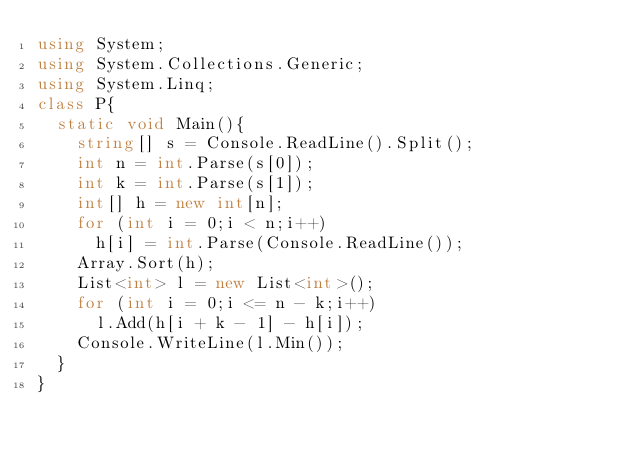<code> <loc_0><loc_0><loc_500><loc_500><_C#_>using System;
using System.Collections.Generic;
using System.Linq;
class P{
  static void Main(){
    string[] s = Console.ReadLine().Split();
    int n = int.Parse(s[0]);
    int k = int.Parse(s[1]);
    int[] h = new int[n];
    for (int i = 0;i < n;i++)
      h[i] = int.Parse(Console.ReadLine());
    Array.Sort(h);
    List<int> l = new List<int>();
    for (int i = 0;i <= n - k;i++)
      l.Add(h[i + k - 1] - h[i]);
    Console.WriteLine(l.Min());
  }
}</code> 